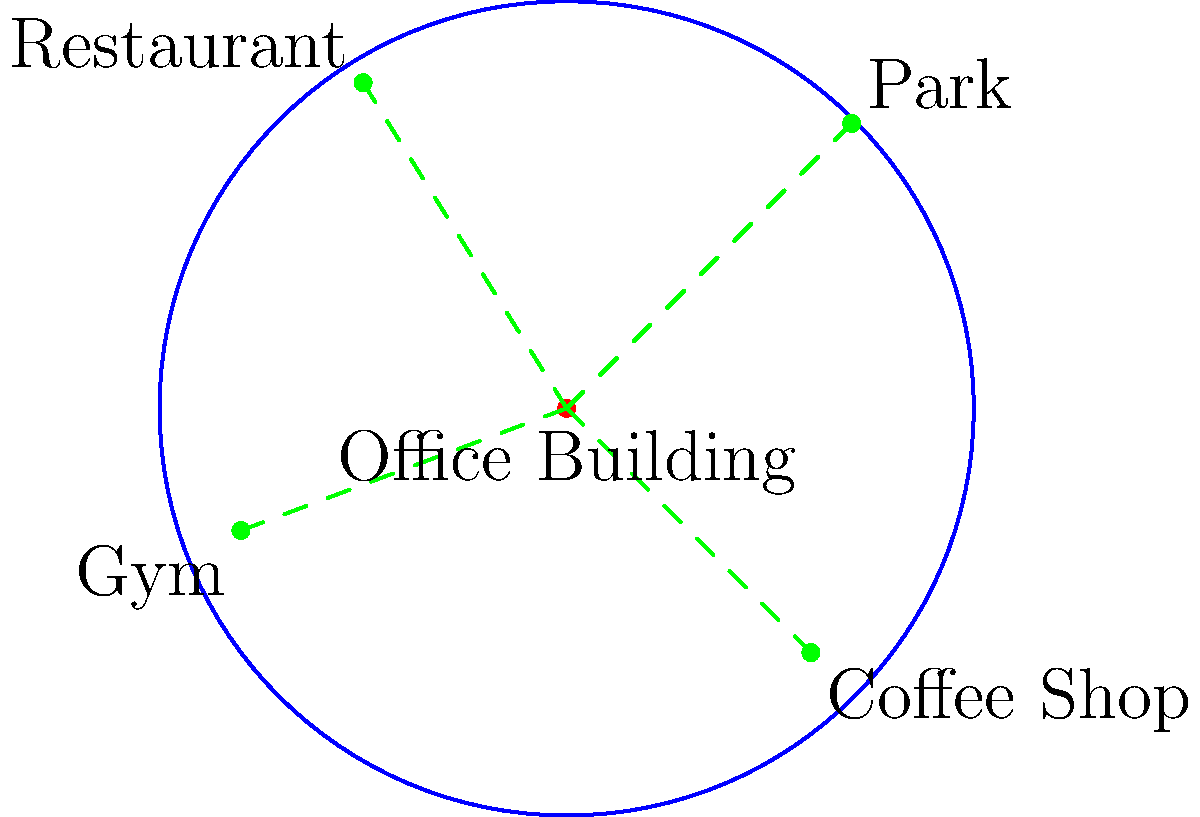Using the radius map provided, which amenity is likely to have the most significant positive impact on the office building's value, assuming all amenities are of equal quality? To determine which amenity has the most significant positive impact on the office building's value, we need to consider the proximity of each amenity to the building. In commercial property appraisal, closer amenities generally have a more significant impact on property value. Let's analyze each amenity:

1. Park (Northeast): Located at approximately (0.7, 0.7) on the unit circle. Its distance from the center is $\sqrt{0.7^2 + 0.7^2} \approx 0.99$.

2. Restaurant (Northwest): Located at approximately (-0.5, 0.8) on the unit circle. Its distance from the center is $\sqrt{(-0.5)^2 + 0.8^2} \approx 0.94$.

3. Gym (Southwest): Located at approximately (-0.8, -0.3) on the unit circle. Its distance from the center is $\sqrt{(-0.8)^2 + (-0.3)^2} \approx 0.85$.

4. Coffee Shop (Southeast): Located at approximately (0.6, -0.6) on the unit circle. Its distance from the center is $\sqrt{0.6^2 + (-0.6)^2} \approx 0.85$.

The gym and coffee shop are equally close to the office building, and they are the closest among all amenities. However, a coffee shop typically has a more direct positive impact on office building value compared to a gym. Coffee shops provide a convenient place for quick meetings, breaks, and can enhance the overall work environment for office tenants.

Therefore, the coffee shop is likely to have the most significant positive impact on the office building's value, given its proximity and relevance to office workers.
Answer: Coffee Shop 